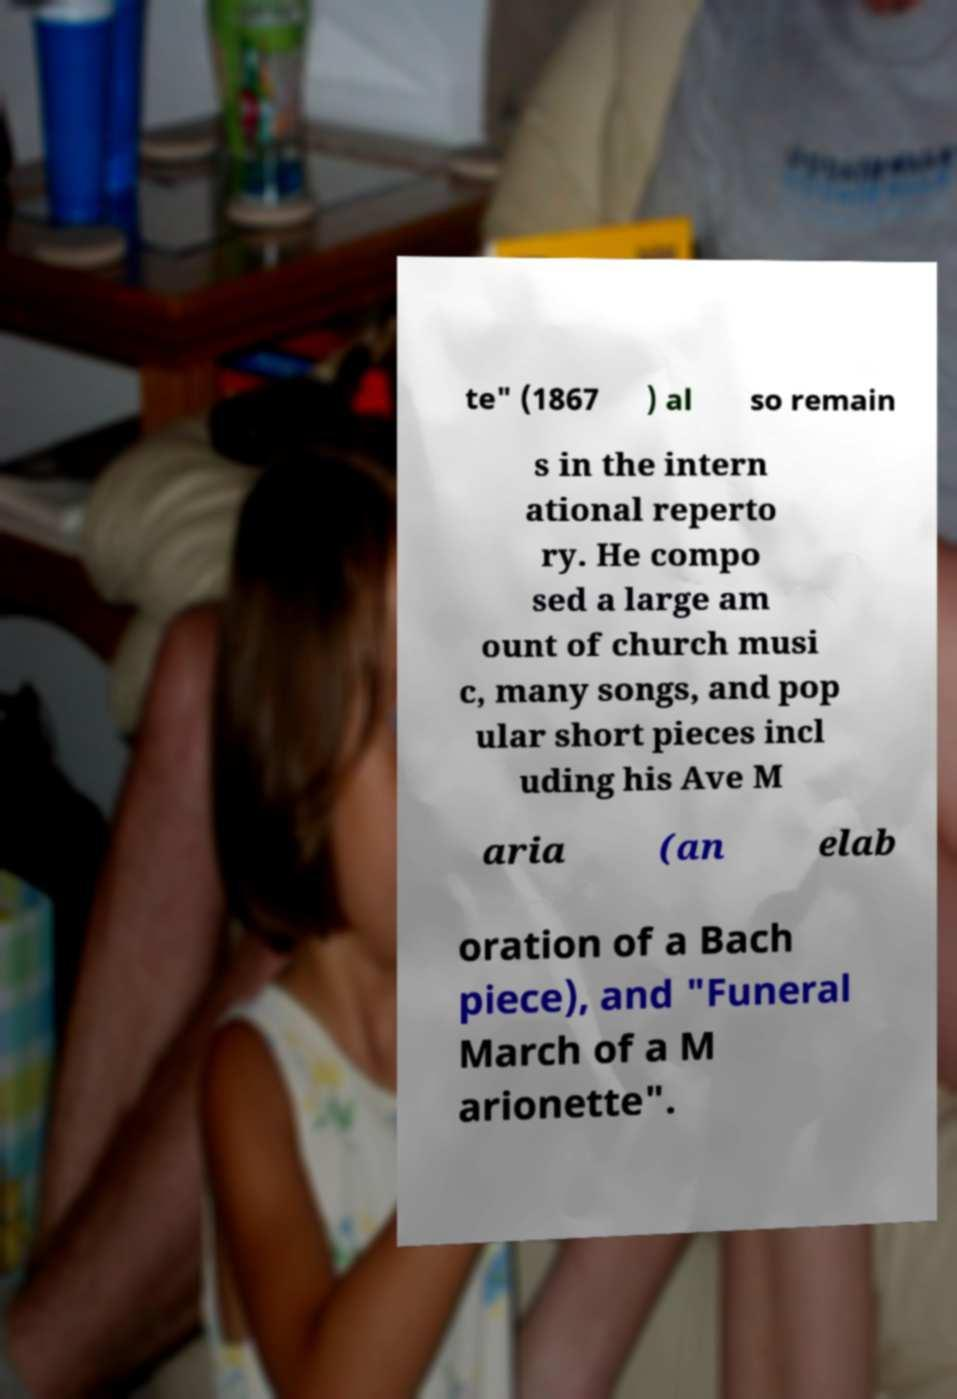There's text embedded in this image that I need extracted. Can you transcribe it verbatim? te" (1867 ) al so remain s in the intern ational reperto ry. He compo sed a large am ount of church musi c, many songs, and pop ular short pieces incl uding his Ave M aria (an elab oration of a Bach piece), and "Funeral March of a M arionette". 